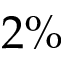<formula> <loc_0><loc_0><loc_500><loc_500>2 \%</formula> 